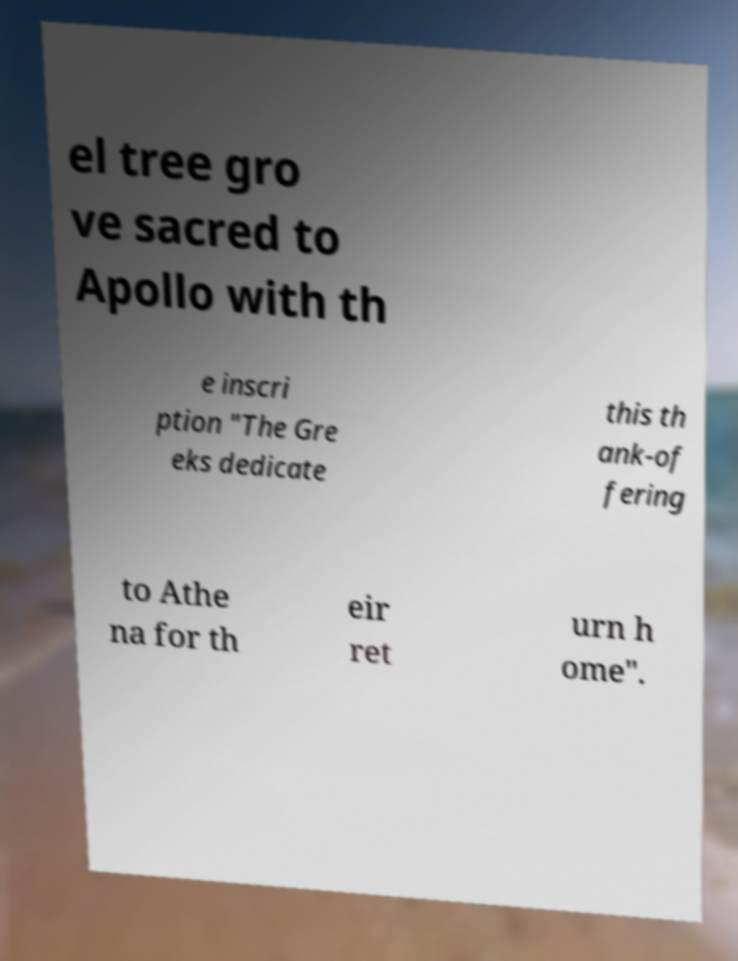Can you read and provide the text displayed in the image?This photo seems to have some interesting text. Can you extract and type it out for me? el tree gro ve sacred to Apollo with th e inscri ption "The Gre eks dedicate this th ank-of fering to Athe na for th eir ret urn h ome". 